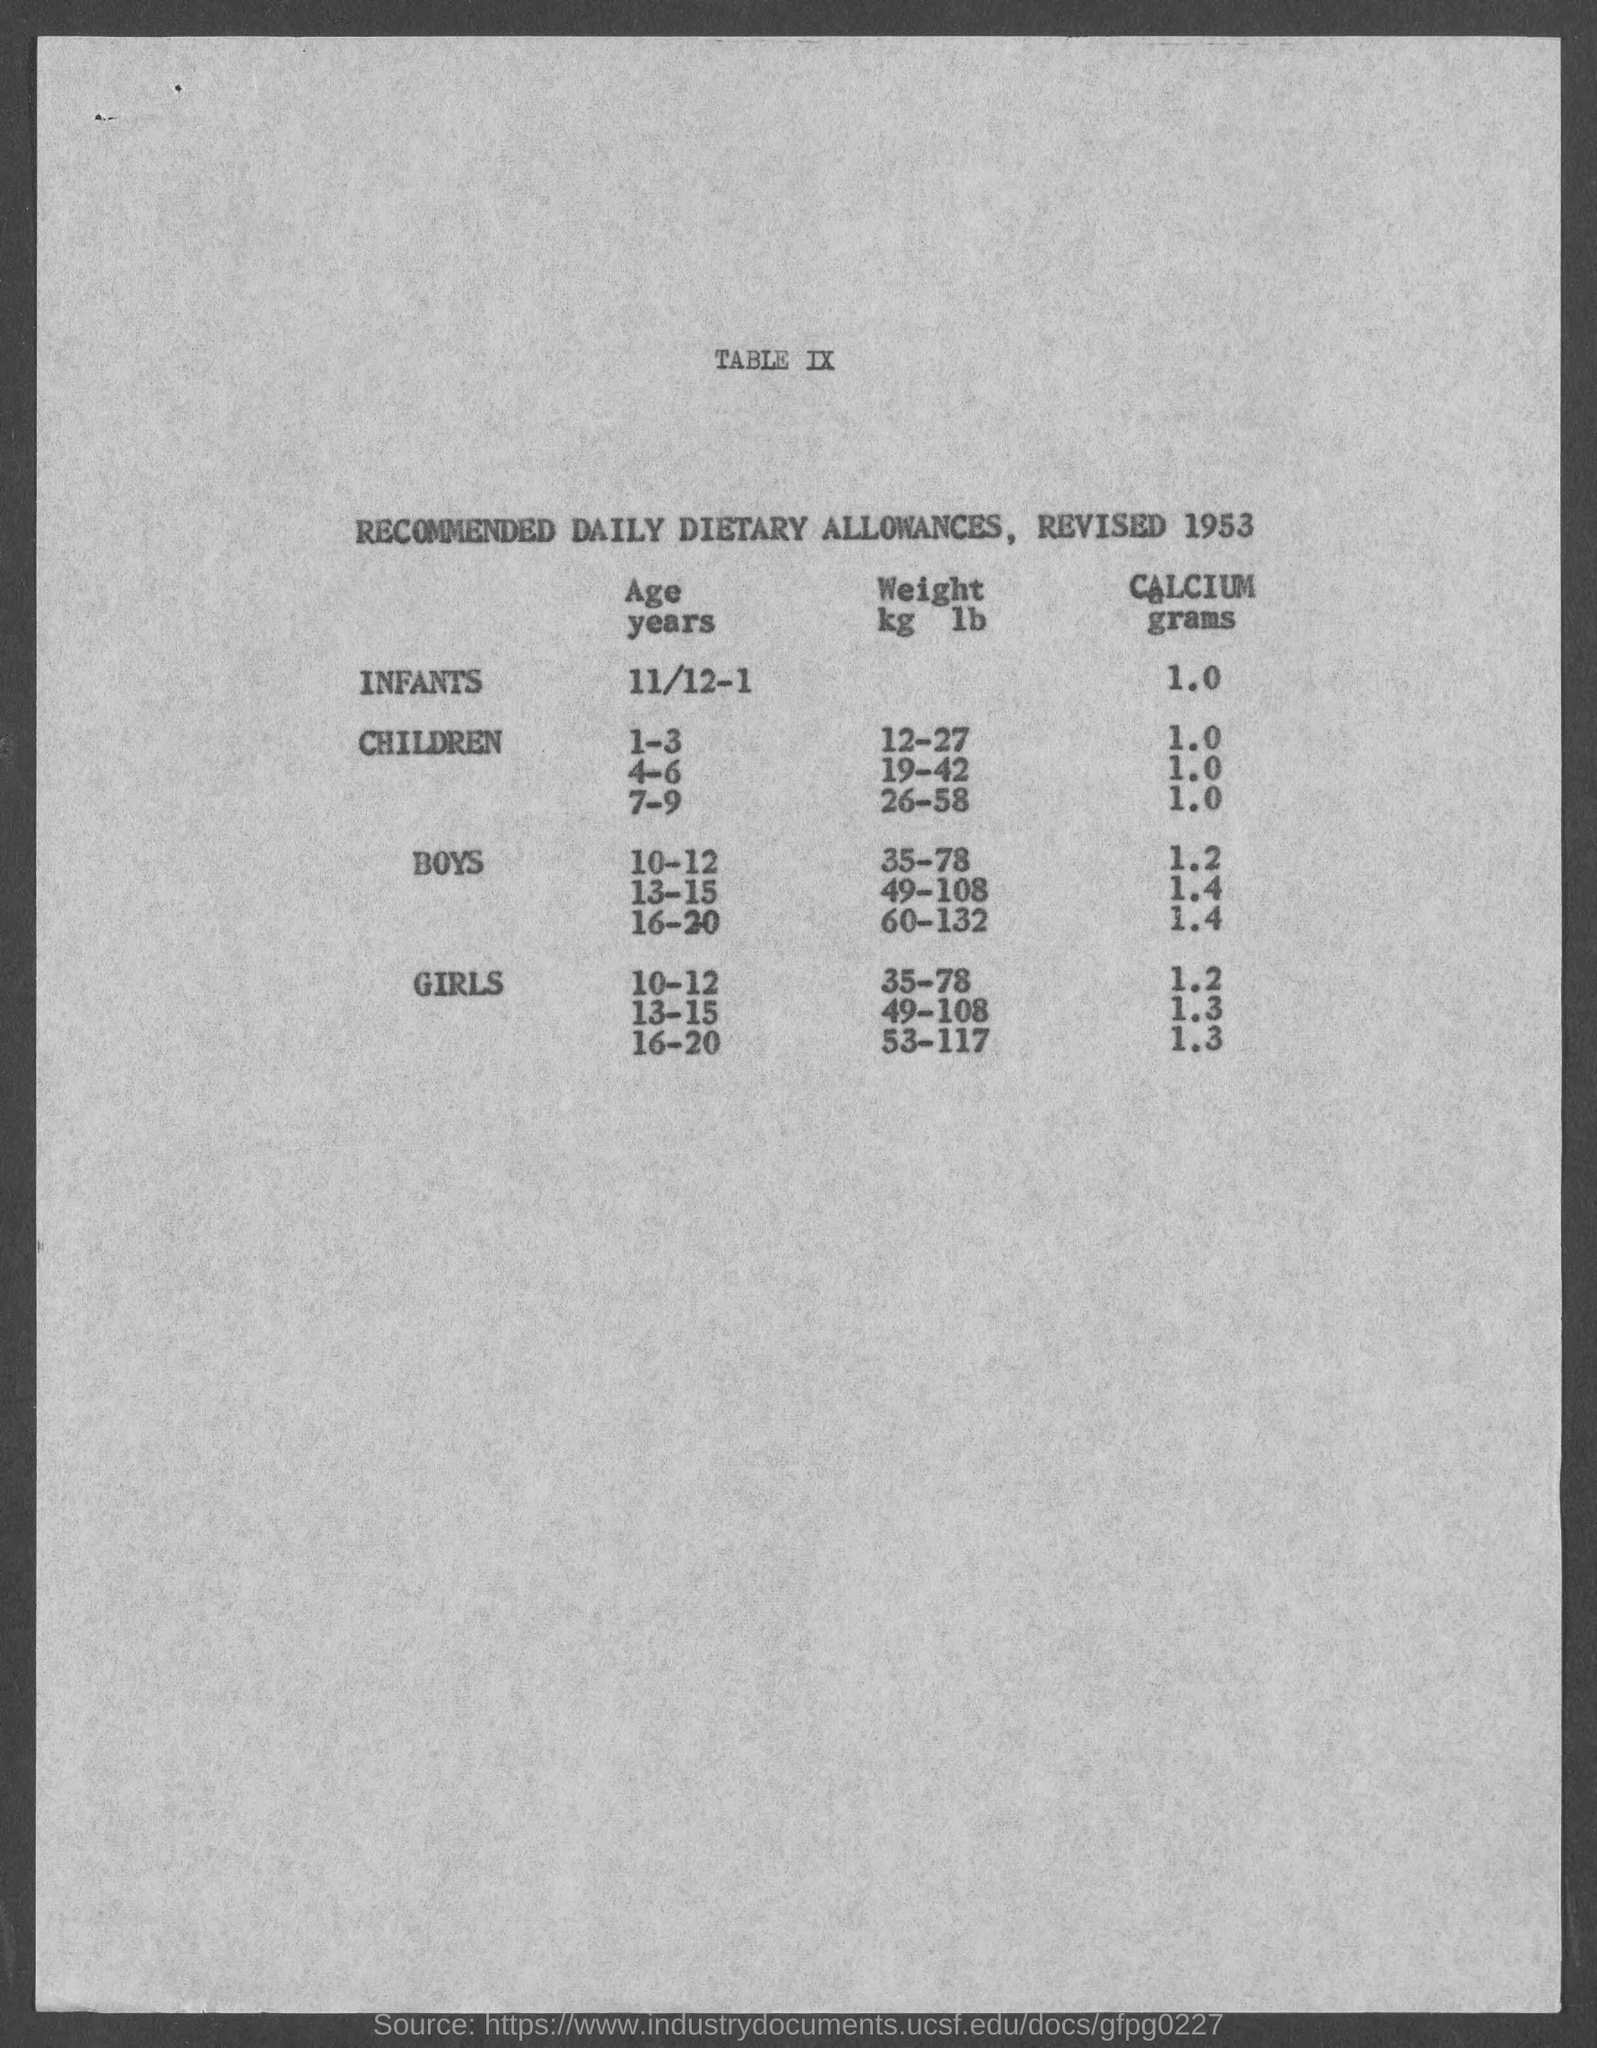Are there any health recommendations for girls in the same age group in the document? Yes, the document provides recommendations for girls as well. For the age group of 10-12 years, the recommended weight range is 35-78 kilograms (77-172 pounds), identical to that for boys of the same age. The recommended calcium intake is slightly higher at 1.3 grams. 